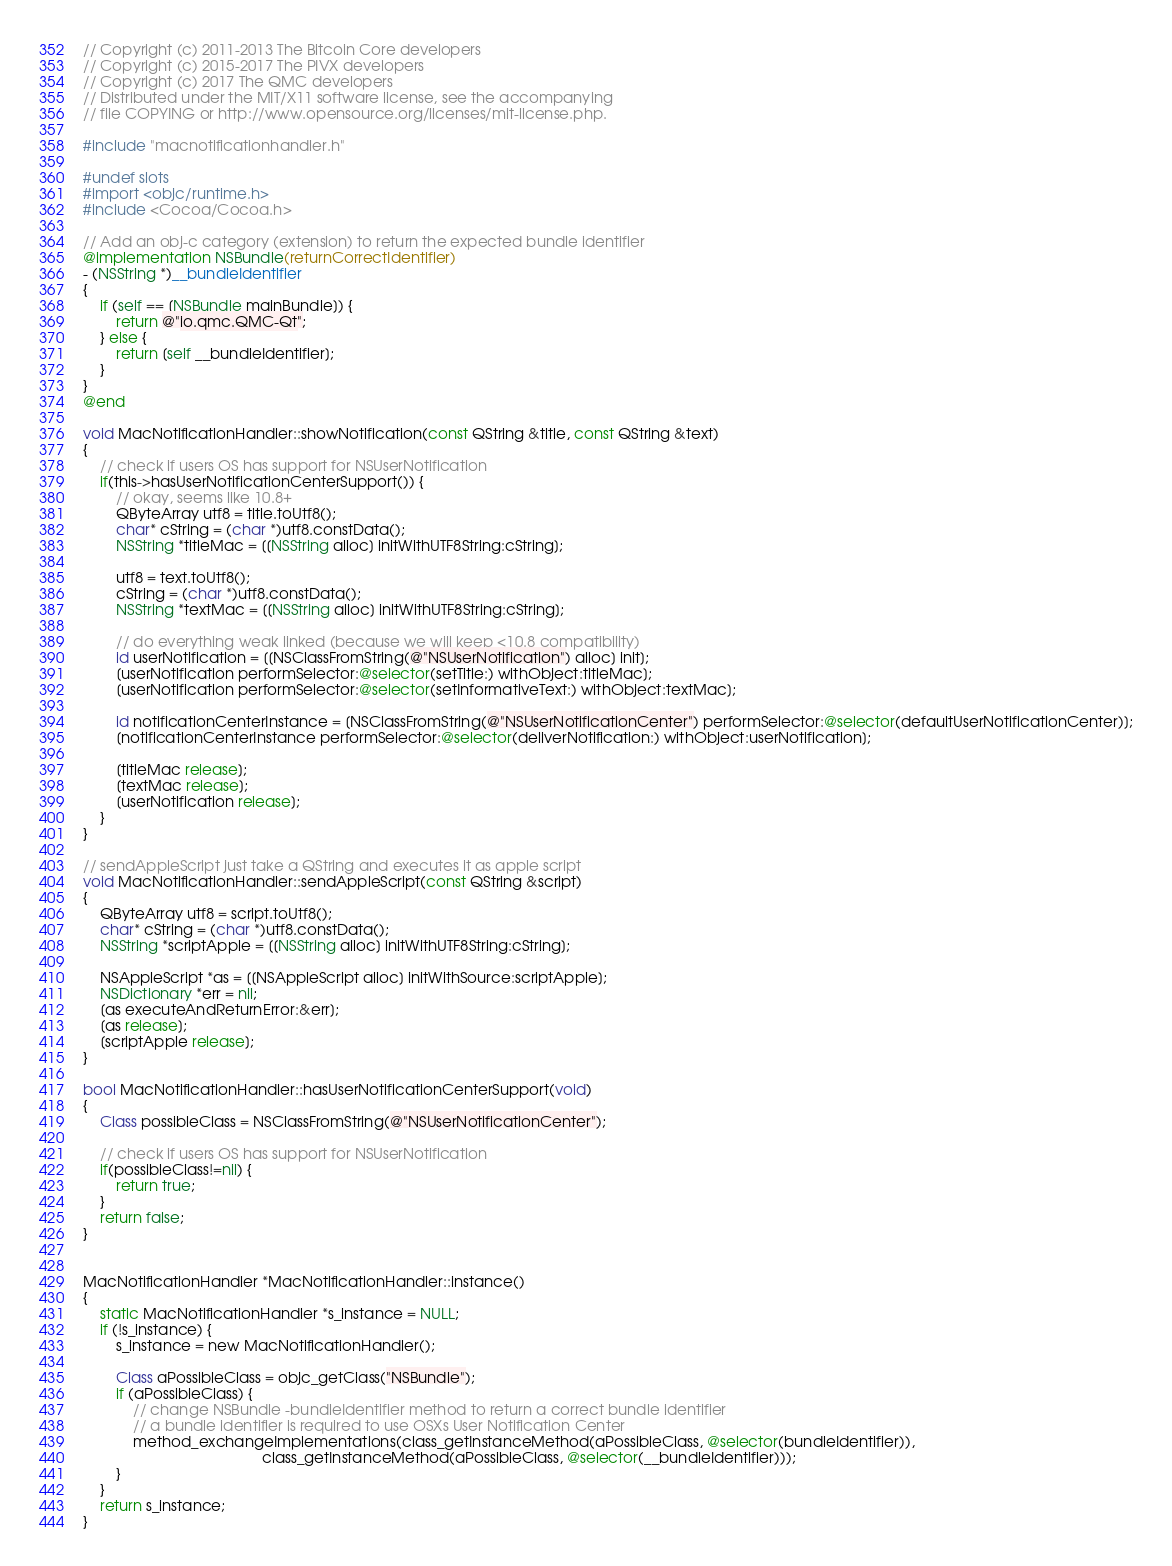Convert code to text. <code><loc_0><loc_0><loc_500><loc_500><_ObjectiveC_>// Copyright (c) 2011-2013 The Bitcoin Core developers
// Copyright (c) 2015-2017 The PIVX developers
// Copyright (c) 2017 The QMC developers
// Distributed under the MIT/X11 software license, see the accompanying
// file COPYING or http://www.opensource.org/licenses/mit-license.php.

#include "macnotificationhandler.h"

#undef slots
#import <objc/runtime.h>
#include <Cocoa/Cocoa.h>

// Add an obj-c category (extension) to return the expected bundle identifier
@implementation NSBundle(returnCorrectIdentifier)
- (NSString *)__bundleIdentifier
{
    if (self == [NSBundle mainBundle]) {
        return @"io.qmc.QMC-Qt";
    } else {
        return [self __bundleIdentifier];
    }
}
@end

void MacNotificationHandler::showNotification(const QString &title, const QString &text)
{
    // check if users OS has support for NSUserNotification
    if(this->hasUserNotificationCenterSupport()) {
        // okay, seems like 10.8+
        QByteArray utf8 = title.toUtf8();
        char* cString = (char *)utf8.constData();
        NSString *titleMac = [[NSString alloc] initWithUTF8String:cString];

        utf8 = text.toUtf8();
        cString = (char *)utf8.constData();
        NSString *textMac = [[NSString alloc] initWithUTF8String:cString];

        // do everything weak linked (because we will keep <10.8 compatibility)
        id userNotification = [[NSClassFromString(@"NSUserNotification") alloc] init];
        [userNotification performSelector:@selector(setTitle:) withObject:titleMac];
        [userNotification performSelector:@selector(setInformativeText:) withObject:textMac];

        id notificationCenterInstance = [NSClassFromString(@"NSUserNotificationCenter") performSelector:@selector(defaultUserNotificationCenter)];
        [notificationCenterInstance performSelector:@selector(deliverNotification:) withObject:userNotification];

        [titleMac release];
        [textMac release];
        [userNotification release];
    }
}

// sendAppleScript just take a QString and executes it as apple script
void MacNotificationHandler::sendAppleScript(const QString &script)
{
    QByteArray utf8 = script.toUtf8();
    char* cString = (char *)utf8.constData();
    NSString *scriptApple = [[NSString alloc] initWithUTF8String:cString];

    NSAppleScript *as = [[NSAppleScript alloc] initWithSource:scriptApple];
    NSDictionary *err = nil;
    [as executeAndReturnError:&err];
    [as release];
    [scriptApple release];
}

bool MacNotificationHandler::hasUserNotificationCenterSupport(void)
{
    Class possibleClass = NSClassFromString(@"NSUserNotificationCenter");

    // check if users OS has support for NSUserNotification
    if(possibleClass!=nil) {
        return true;
    }
    return false;
}


MacNotificationHandler *MacNotificationHandler::instance()
{
    static MacNotificationHandler *s_instance = NULL;
    if (!s_instance) {
        s_instance = new MacNotificationHandler();
        
        Class aPossibleClass = objc_getClass("NSBundle");
        if (aPossibleClass) {
            // change NSBundle -bundleIdentifier method to return a correct bundle identifier
            // a bundle identifier is required to use OSXs User Notification Center
            method_exchangeImplementations(class_getInstanceMethod(aPossibleClass, @selector(bundleIdentifier)),
                                           class_getInstanceMethod(aPossibleClass, @selector(__bundleIdentifier)));
        }
    }
    return s_instance;
}
</code> 